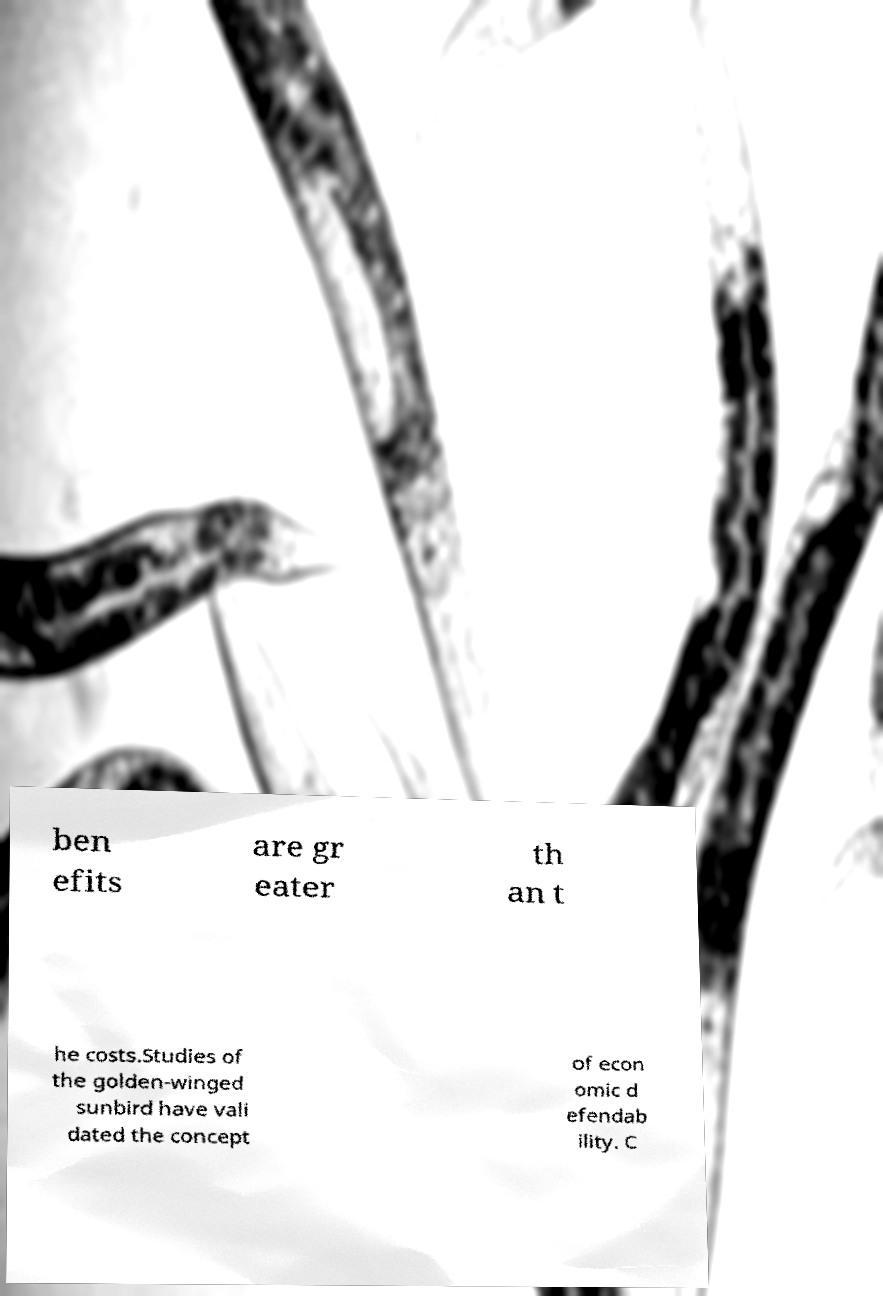Could you assist in decoding the text presented in this image and type it out clearly? ben efits are gr eater th an t he costs.Studies of the golden-winged sunbird have vali dated the concept of econ omic d efendab ility. C 